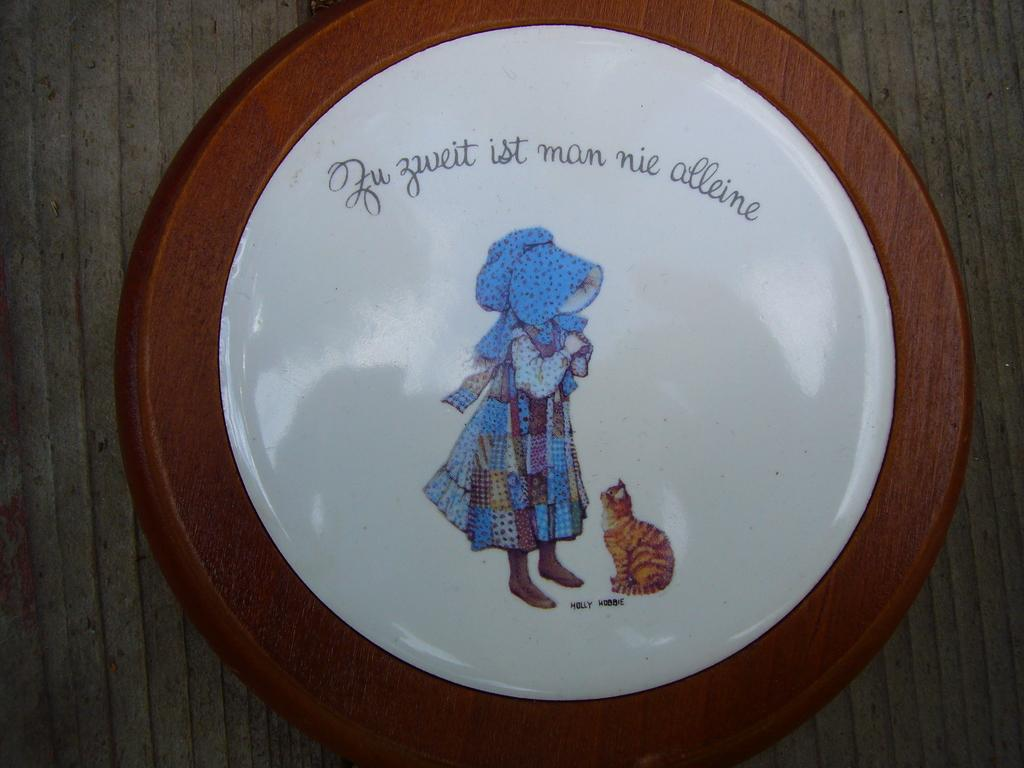What object is the main subject of the image? The main subject of the image is a coin. What is depicted on the coin? The coin has a picture of a person and a cat on it. Are there any words on the coin? Yes, there is text written on the coin. What type of vase is shown in the background of the image? There is no vase present in the image; it only features a coin with images of a person and a cat, along with text. Can you tell me what the cook is preparing in the image? There is no cook or any food preparation depicted in the image; it only features a coin. 